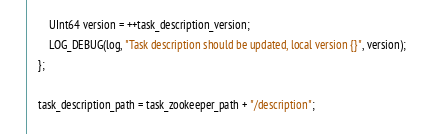<code> <loc_0><loc_0><loc_500><loc_500><_C++_>        UInt64 version = ++task_description_version;
        LOG_DEBUG(log, "Task description should be updated, local version {}", version);
    };

    task_description_path = task_zookeeper_path + "/description";</code> 